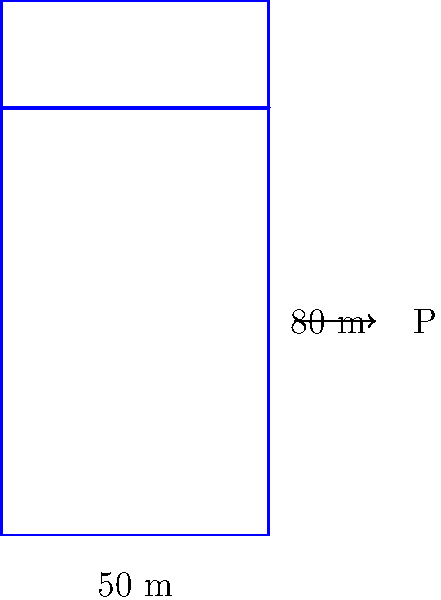In your latest vlog, you're visiting a massive dam for a dramatic scene. The dam wall is 80 meters high and 50 meters wide. Assuming the water level is at the top of the dam, calculate the total water pressure on the dam wall. Use the formula $P = \frac{1}{2} \rho g h^2 w$, where $\rho$ is the density of water (1000 kg/m³), $g$ is the acceleration due to gravity (9.81 m/s²), $h$ is the height of the water, and $w$ is the width of the dam. Express your answer in mega-newtons (MN). Let's break this down step-by-step:

1) We're given:
   $\rho = 1000$ kg/m³
   $g = 9.81$ m/s²
   $h = 80$ m
   $w = 50$ m

2) The formula for pressure is:
   $P = \frac{1}{2} \rho g h^2 w$

3) Let's substitute our values:
   $P = \frac{1}{2} \times 1000 \times 9.81 \times 80^2 \times 50$

4) Calculate:
   $P = 0.5 \times 1000 \times 9.81 \times 6400 \times 50$
   $P = 1,569,600,000$ N

5) Convert to mega-newtons:
   $P = 1,569.6$ MN

This massive pressure would make for a dramatic reveal in your vlog!
Answer: 1,569.6 MN 